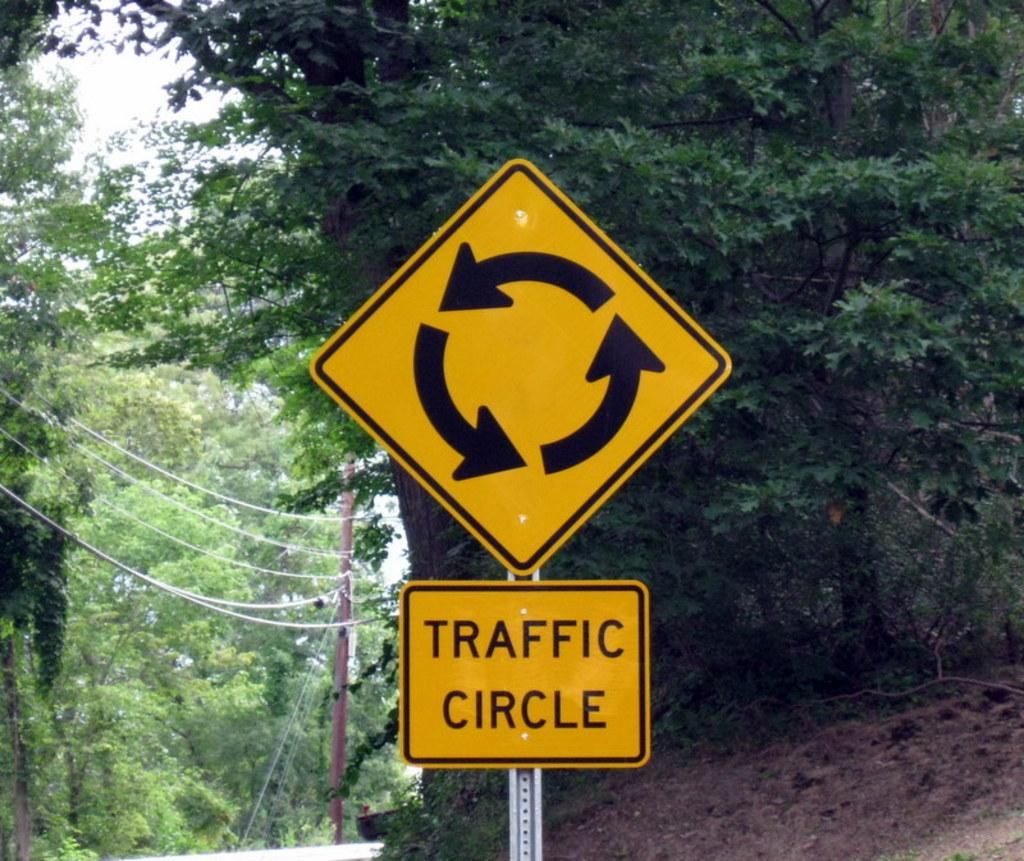<image>
Provide a brief description of the given image. Yellow sign which says "traffic Circle" by some trees. 